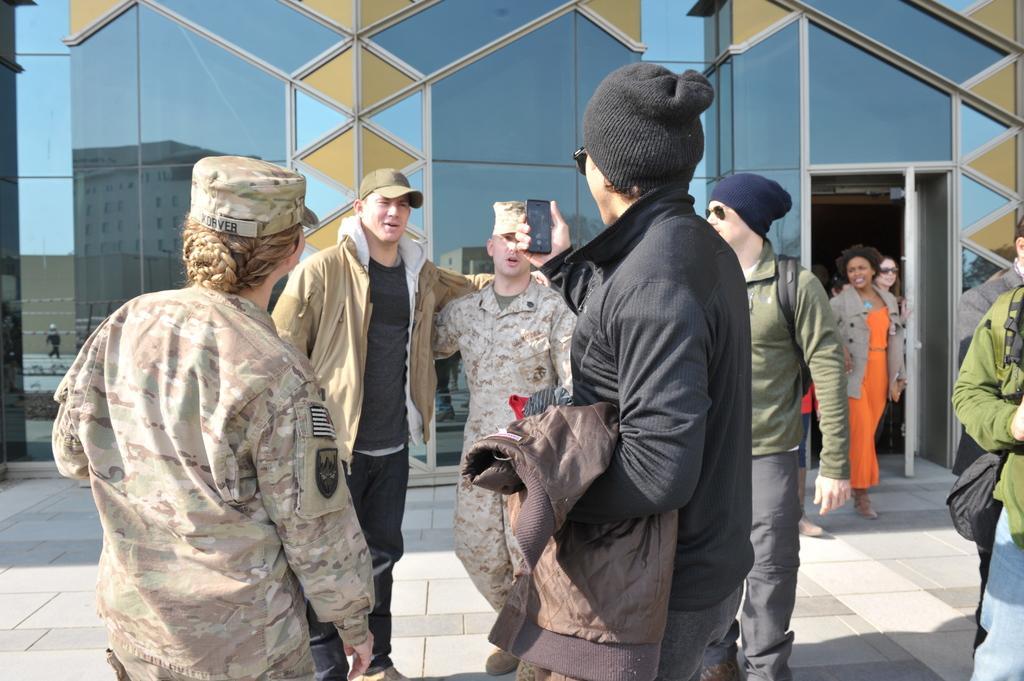Could you give a brief overview of what you see in this image? In this image we can see persons standing on the floor. In the background there is a building with glasses. 